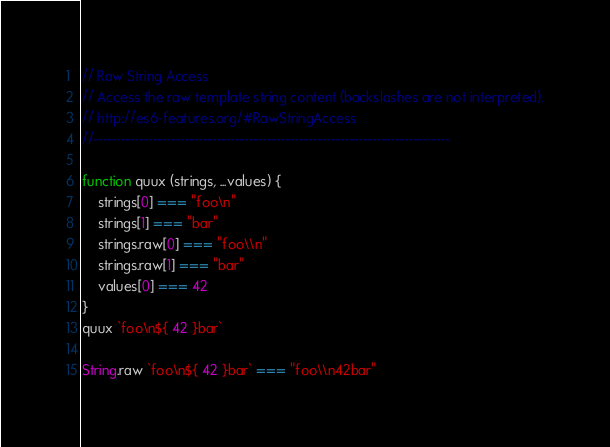<code> <loc_0><loc_0><loc_500><loc_500><_JavaScript_>// Raw String Access
// Access the raw template string content (backslashes are not interpreted).
// http://es6-features.org/#RawStringAccess
//------------------------------------------------------------------------------

function quux (strings, ...values) {
    strings[0] === "foo\n"
    strings[1] === "bar"
    strings.raw[0] === "foo\\n"
    strings.raw[1] === "bar"
    values[0] === 42
}
quux `foo\n${ 42 }bar`

String.raw `foo\n${ 42 }bar` === "foo\\n42bar"</code> 